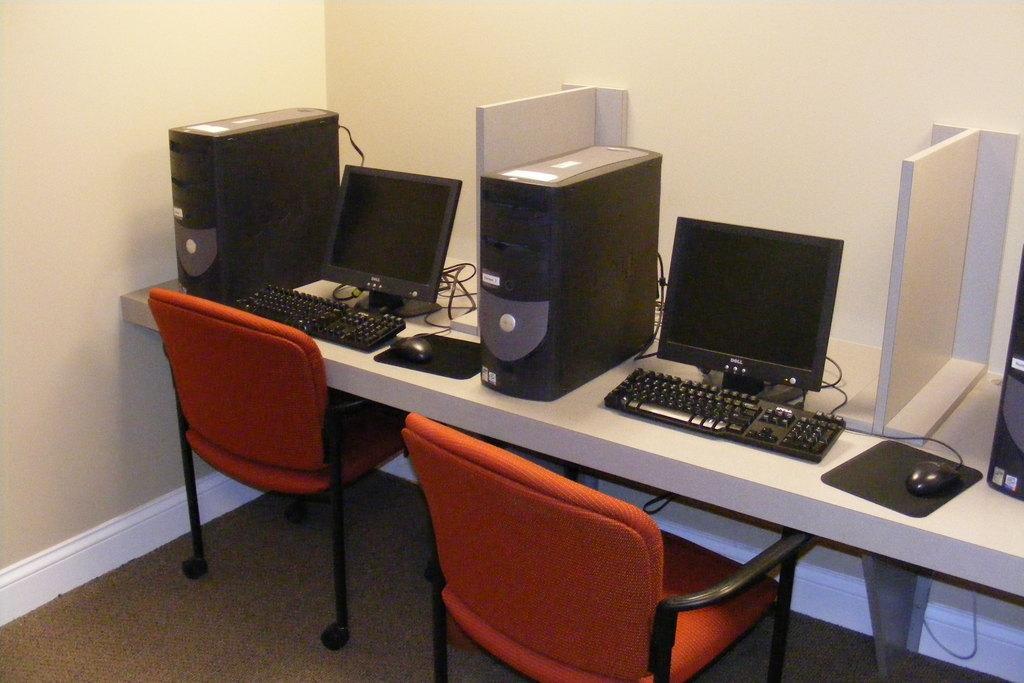Describe this image in one or two sentences. In the image we can see on the table there are monitors, cpu and infront it there are chairs. 